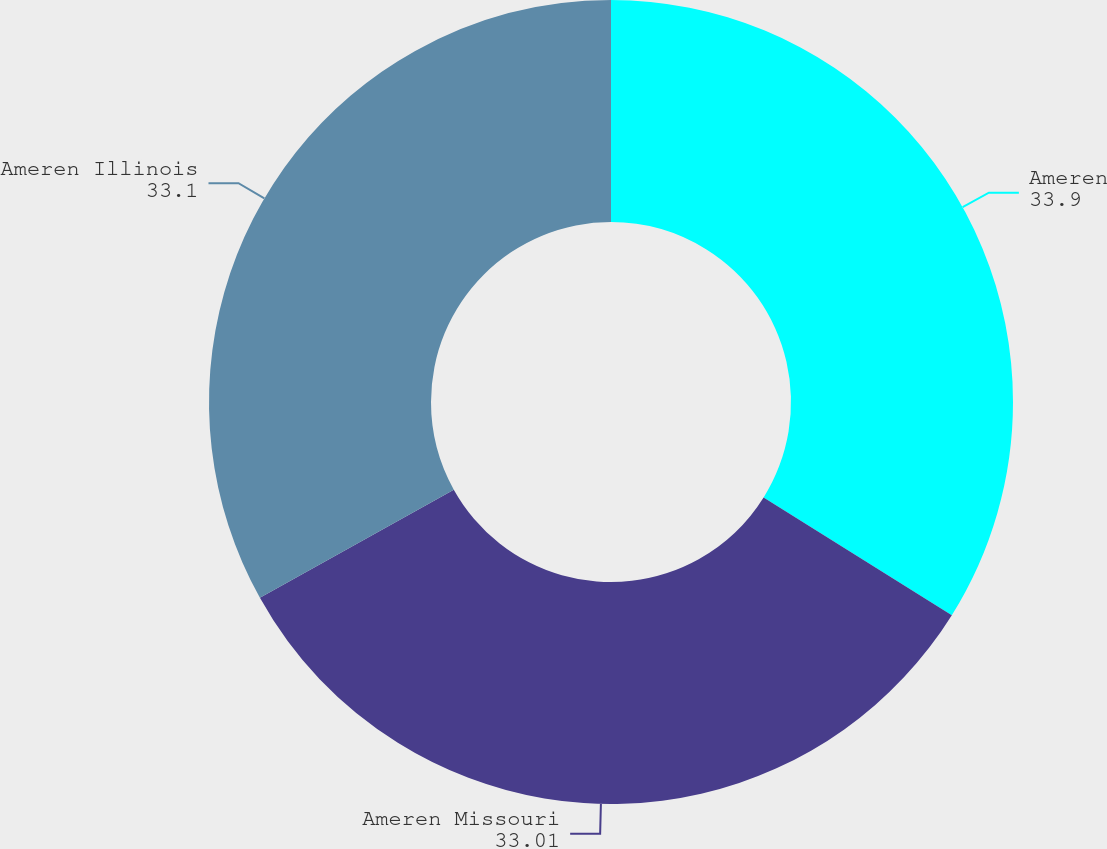<chart> <loc_0><loc_0><loc_500><loc_500><pie_chart><fcel>Ameren<fcel>Ameren Missouri<fcel>Ameren Illinois<nl><fcel>33.9%<fcel>33.01%<fcel>33.1%<nl></chart> 